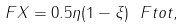Convert formula to latex. <formula><loc_0><loc_0><loc_500><loc_500>\ F X = 0 . 5 \eta ( 1 - \xi ) \ F t o t ,</formula> 